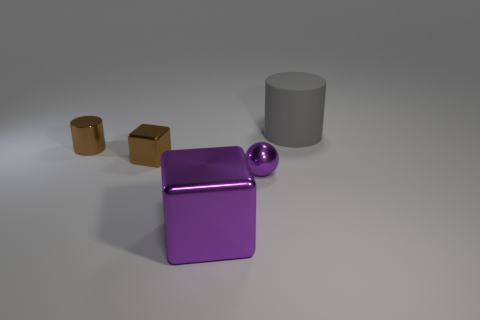Add 1 green balls. How many objects exist? 6 Subtract all cylinders. How many objects are left? 3 Subtract 0 yellow blocks. How many objects are left? 5 Subtract all big purple objects. Subtract all big gray rubber cylinders. How many objects are left? 3 Add 4 big matte cylinders. How many big matte cylinders are left? 5 Add 5 purple shiny balls. How many purple shiny balls exist? 6 